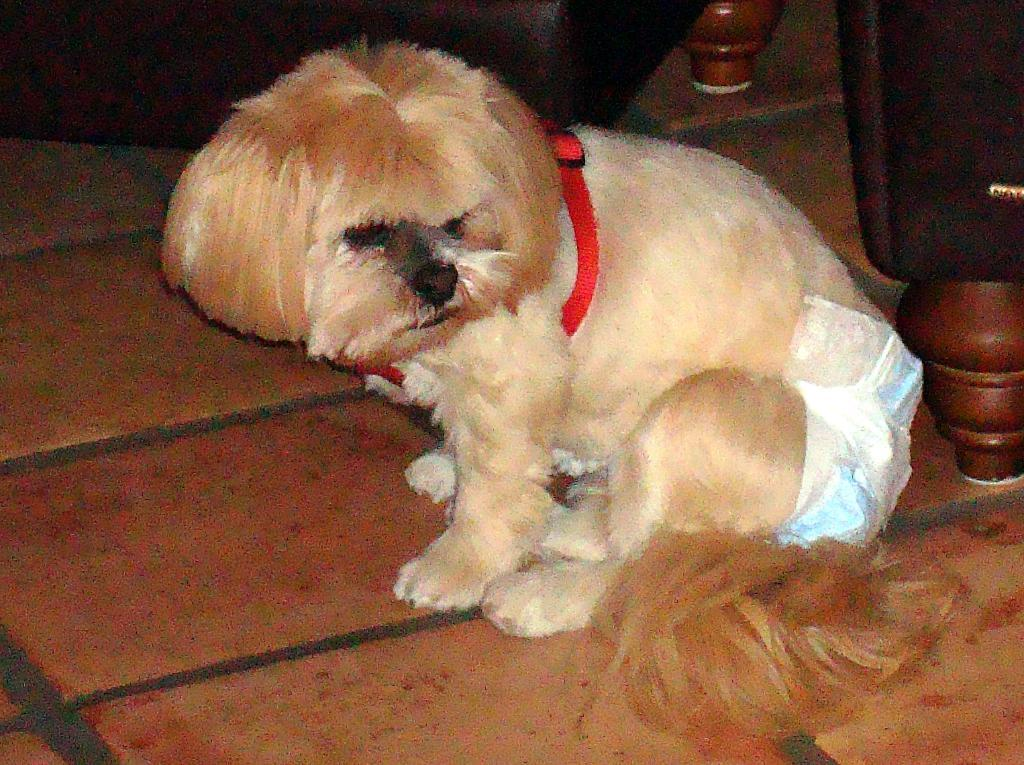What type of animal is in the image? There is a dog in the image. Where is the dog located in the image? The dog is on the floor. What other objects can be seen in the image? There are wooden poles in the image. What letter does the dog use to communicate in the image? Dogs do not use letters to communicate; they use body language and vocalizations. 